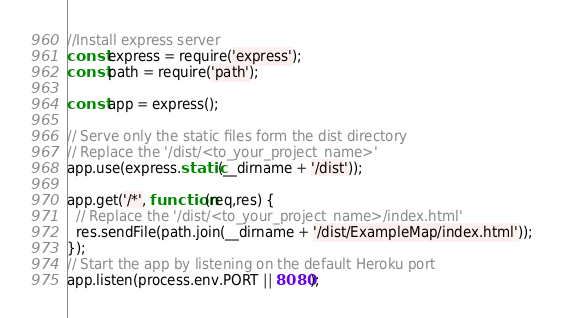<code> <loc_0><loc_0><loc_500><loc_500><_JavaScript_>//Install express server
const express = require('express');
const path = require('path');
 
const app = express();
 
// Serve only the static files form the dist directory
// Replace the '/dist/<to_your_project_name>'
app.use(express.static(__dirname + '/dist'));
 
app.get('/*', function(req,res) {
  // Replace the '/dist/<to_your_project_name>/index.html'
  res.sendFile(path.join(__dirname + '/dist/ExampleMap/index.html'));
});
// Start the app by listening on the default Heroku port
app.listen(process.env.PORT || 8080);</code> 